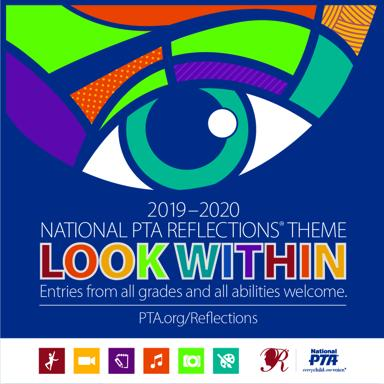What types of artistic categories are represented by the icons at the bottom of the poster? The icons at the bottom of the poster represent various artistic categories in the Reflections program. From left to right, they symbolize dance, film production, literature, music, photography, and visual arts, indicating the diverse forms of expression encouraged by the program. 